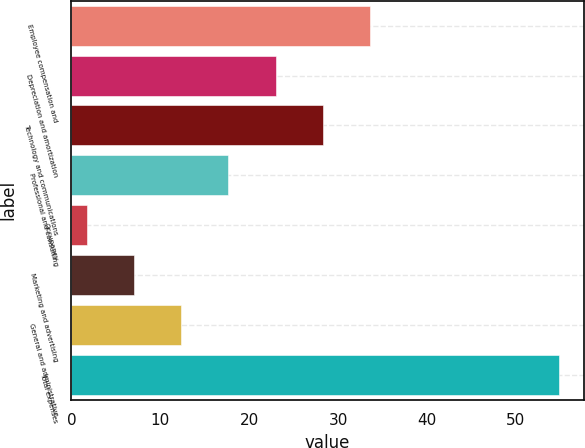<chart> <loc_0><loc_0><loc_500><loc_500><bar_chart><fcel>Employee compensation and<fcel>Depreciation and amortization<fcel>Technology and communications<fcel>Professional and consulting<fcel>Occupancy<fcel>Marketing and advertising<fcel>General and administrative<fcel>Total expenses<nl><fcel>33.62<fcel>22.98<fcel>28.3<fcel>17.66<fcel>1.7<fcel>7.02<fcel>12.34<fcel>54.9<nl></chart> 